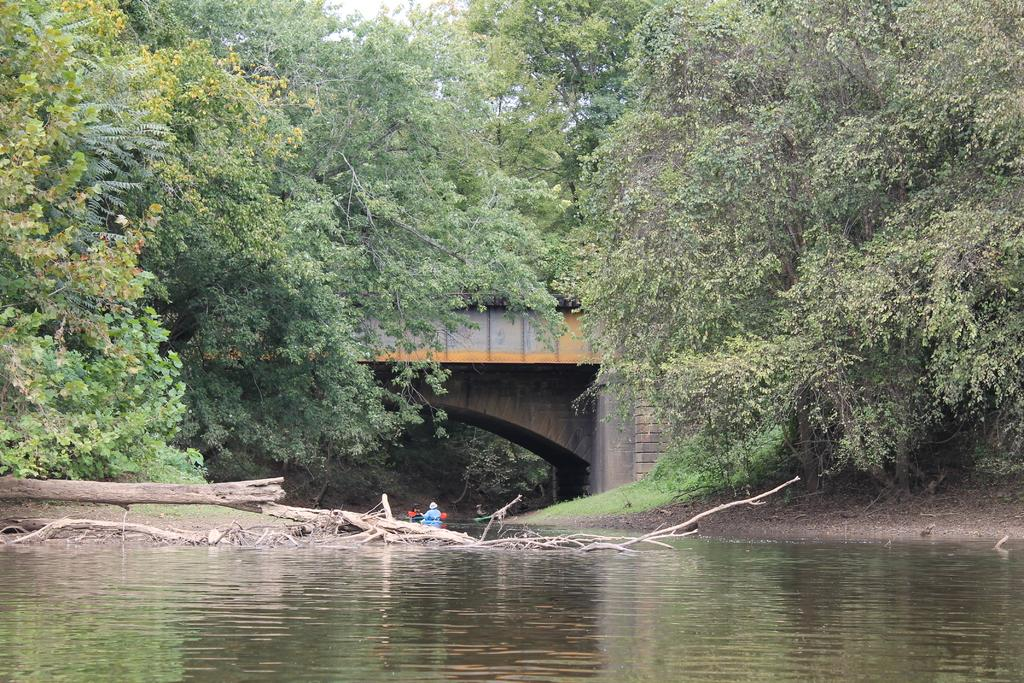What is the primary element in the image? There is water in the image. What can be seen in the water? There are people on an object in the water. What is the object on the water? The object is a boat or a similar floating structure. What is visible at the top of the image? There is a bridge at the top of the image. What is behind the bridge? There are trees behind the bridge. What is visible beyond the trees? The sky is visible behind the trees. What committee is responsible for maintaining the weight of the hot air balloon in the image? There is no hot air balloon present in the image, so there is no committee responsible for maintaining its weight. 